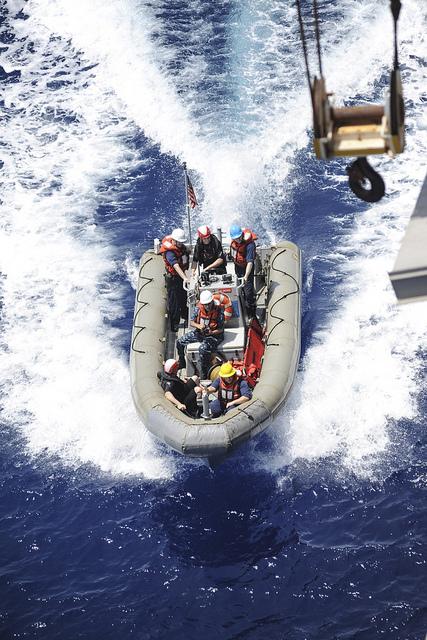What type of boat is shown in the water?
Be succinct. Inflatable. Does the boat have a flag?
Keep it brief. Yes. What time is it?
Answer briefly. Daytime. Is there people in the boat?
Concise answer only. Yes. 